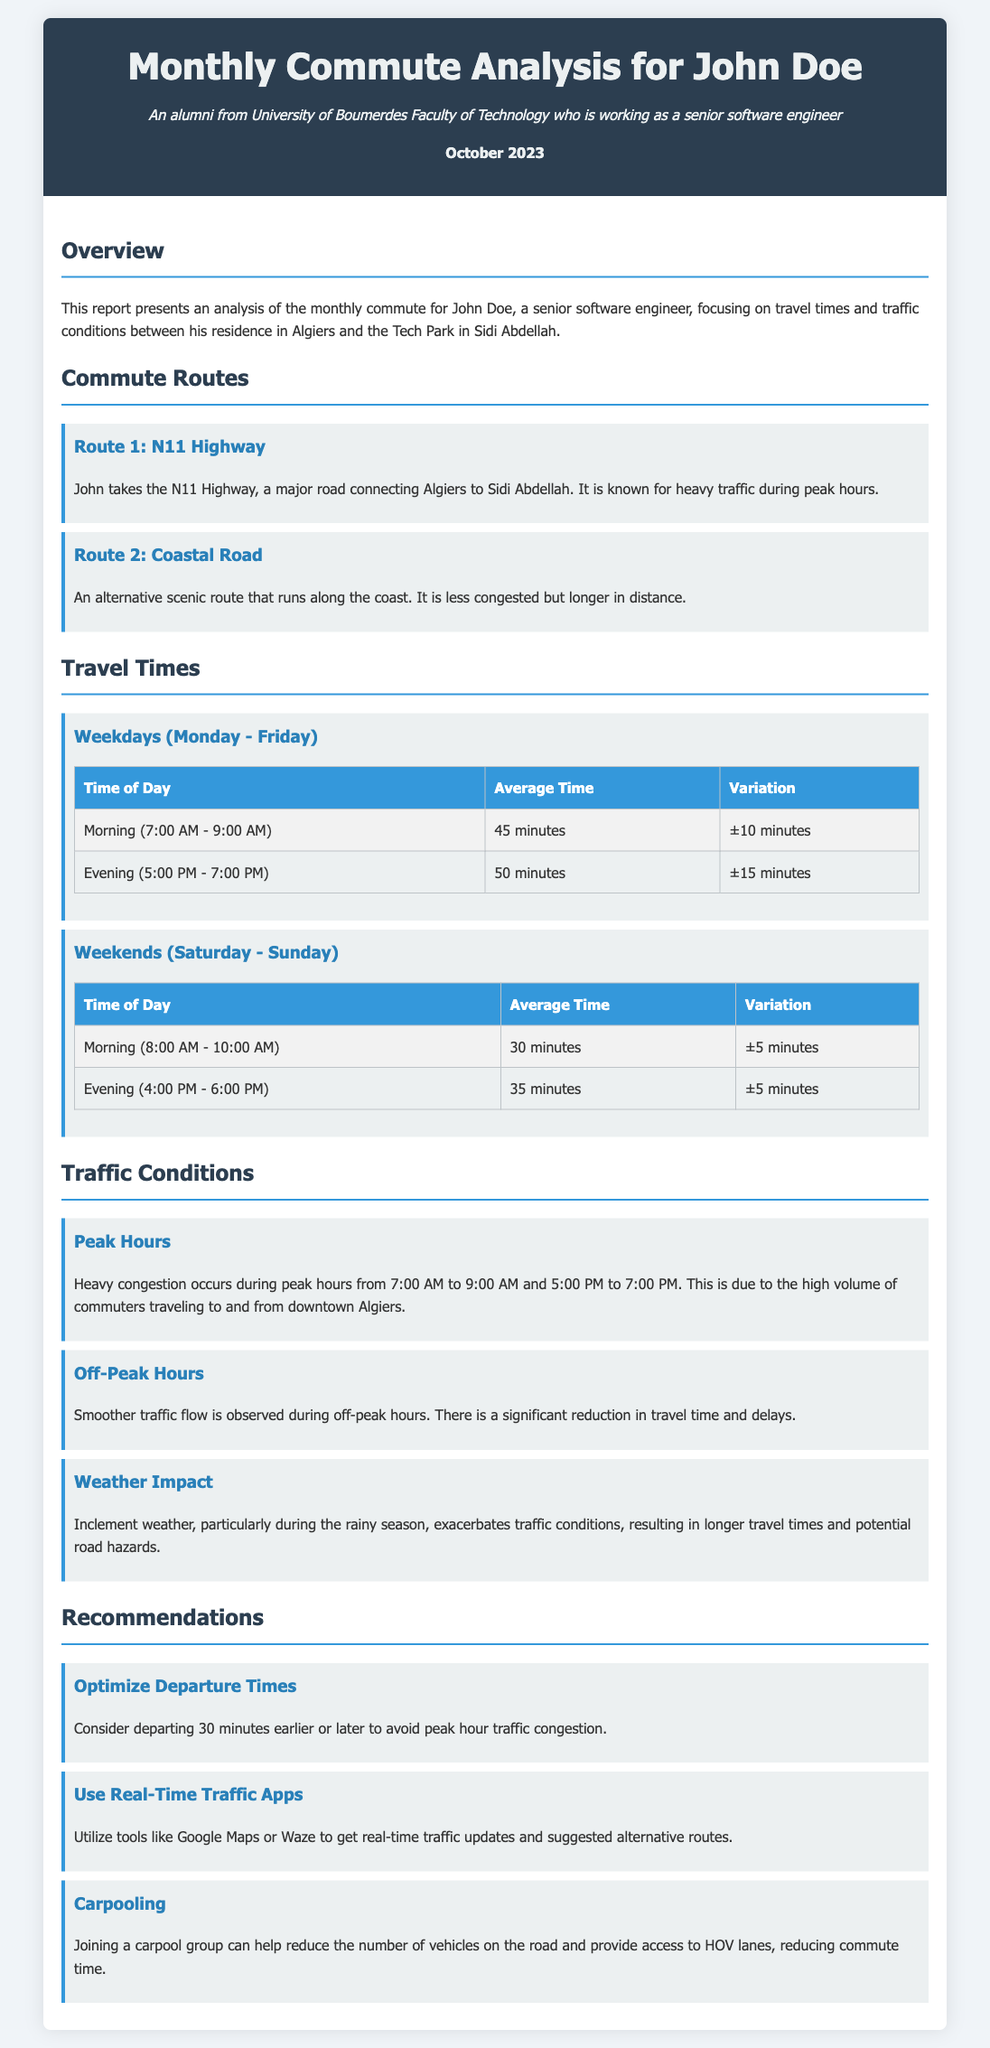What is the title of the report? The title of the report is mentioned in the header section of the document.
Answer: Monthly Commute Analysis for John Doe What is the average travel time for weekdays in the morning? The average travel time is specified in the travel times section for weekdays during the morning.
Answer: 45 minutes What alternative route does John take? The document specifies alternative routes in the Commute Routes section.
Answer: Coastal Road What is the impact of weather on traffic conditions? The effects of weather on traffic are discussed in the Traffic Conditions section.
Answer: Exacerbates traffic conditions What is a recommended action to avoid peak hour congestion? Recommendations are listed in the Recommendations section of the document.
Answer: Departing 30 minutes earlier or later 